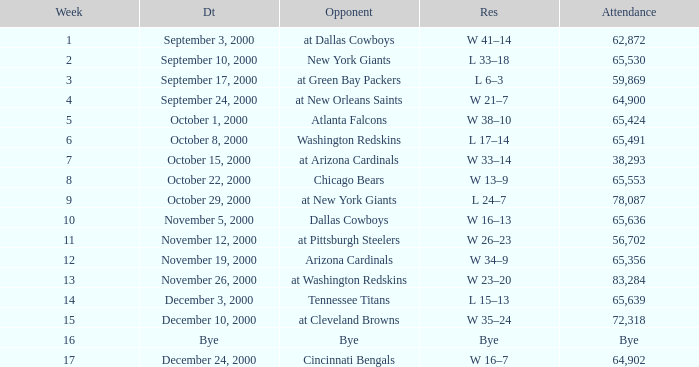What was the attendance for week 2? 65530.0. 